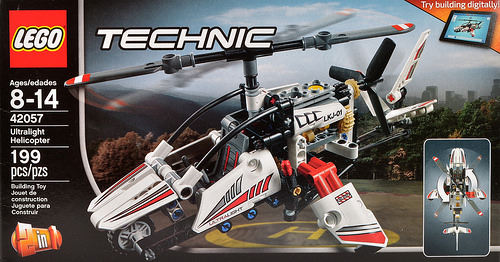<image>
Is there a helicopter toy in front of the box? No. The helicopter toy is not in front of the box. The spatial positioning shows a different relationship between these objects. 